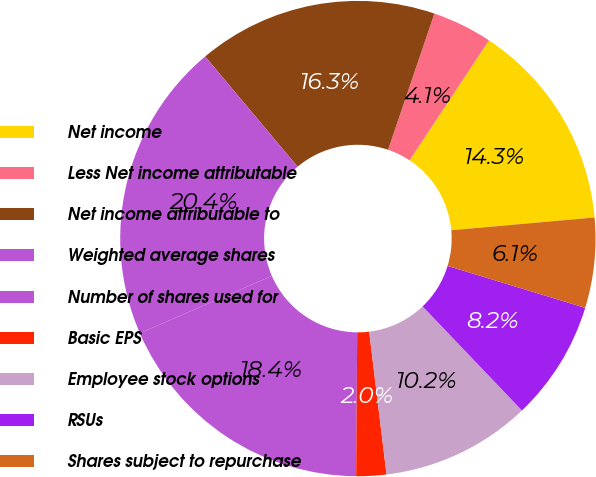<chart> <loc_0><loc_0><loc_500><loc_500><pie_chart><fcel>Net income<fcel>Less Net income attributable<fcel>Net income attributable to<fcel>Weighted average shares<fcel>Number of shares used for<fcel>Basic EPS<fcel>Employee stock options<fcel>RSUs<fcel>Shares subject to repurchase<nl><fcel>14.28%<fcel>4.08%<fcel>16.32%<fcel>20.4%<fcel>18.36%<fcel>2.04%<fcel>10.2%<fcel>8.16%<fcel>6.12%<nl></chart> 